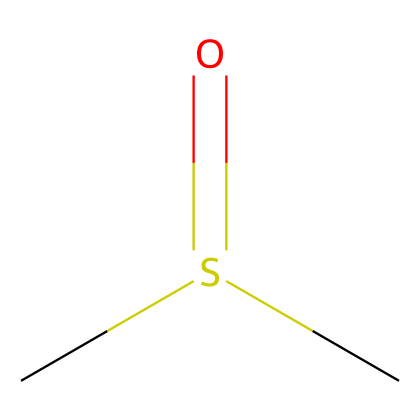What is the molecular formula of this compound? The SMILES representation CS(=O)C indicates that there are two carbon atoms (C), one sulfur atom (S), and one oxygen atom (O). Thus, the molecular formula can be deduced by counting the atoms directly from the SMILES notation.
Answer: C2H6OS How many hydrogen atoms are present in this chemical? From the SMILES notation, CS(=O)C can be interpreted as having two methyl groups (CH3) attached to the sulfur atom, each contributing three hydrogen atoms. Therefore, the total number of hydrogen atoms is six.
Answer: 6 What type of functional group is present in this compound? The molecule contains the sulfoxide group (R-S(=O)-R'), which is represented in the SMILES by the (S=O) part. This functional group is characteristic of dimethyl sulfoxide.
Answer: sulfoxide What is the oxidation state of sulfur in dimethyl sulfoxide? In this compound, sulfur is bonded to one oxygen atom via a double bond and two carbon atoms. By calculating, sulfur's oxidation state is +2 due to its bonding scenario and the need to balance overall charge.
Answer: +2 Why is this compound used for preserving historical documents? Dimethyl sulfoxide has unique solvent properties that allow it to effectively dissolve both polar and nonpolar compounds, facilitating the preservation process of various materials found in historical documents.
Answer: solvent properties 